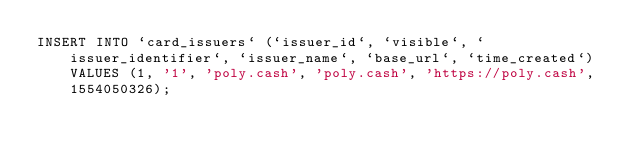<code> <loc_0><loc_0><loc_500><loc_500><_SQL_>INSERT INTO `card_issuers` (`issuer_id`, `visible`, `issuer_identifier`, `issuer_name`, `base_url`, `time_created`) VALUES (1, '1', 'poly.cash', 'poly.cash', 'https://poly.cash', 1554050326);
</code> 